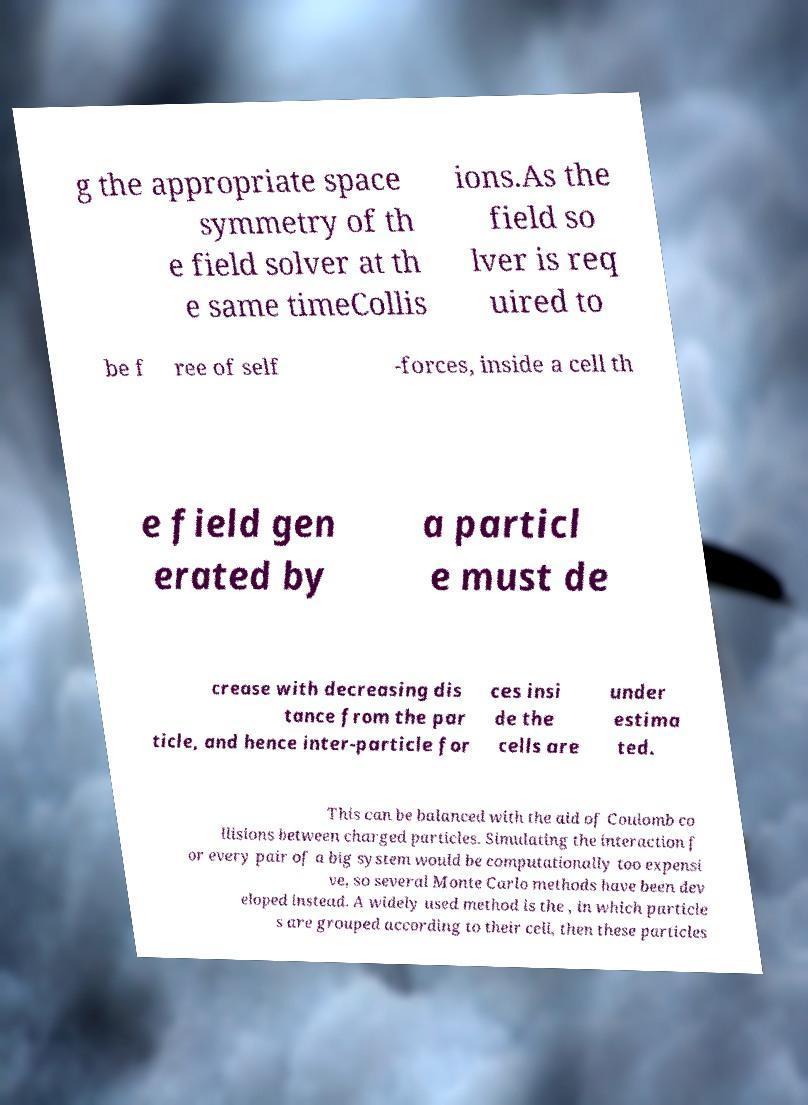For documentation purposes, I need the text within this image transcribed. Could you provide that? g the appropriate space symmetry of th e field solver at th e same timeCollis ions.As the field so lver is req uired to be f ree of self -forces, inside a cell th e field gen erated by a particl e must de crease with decreasing dis tance from the par ticle, and hence inter-particle for ces insi de the cells are under estima ted. This can be balanced with the aid of Coulomb co llisions between charged particles. Simulating the interaction f or every pair of a big system would be computationally too expensi ve, so several Monte Carlo methods have been dev eloped instead. A widely used method is the , in which particle s are grouped according to their cell, then these particles 